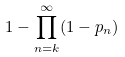Convert formula to latex. <formula><loc_0><loc_0><loc_500><loc_500>1 - \prod _ { n = k } ^ { \infty } ( 1 - p _ { n } )</formula> 